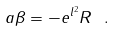Convert formula to latex. <formula><loc_0><loc_0><loc_500><loc_500>a \beta = - e ^ { l ^ { 2 } } R \ .</formula> 